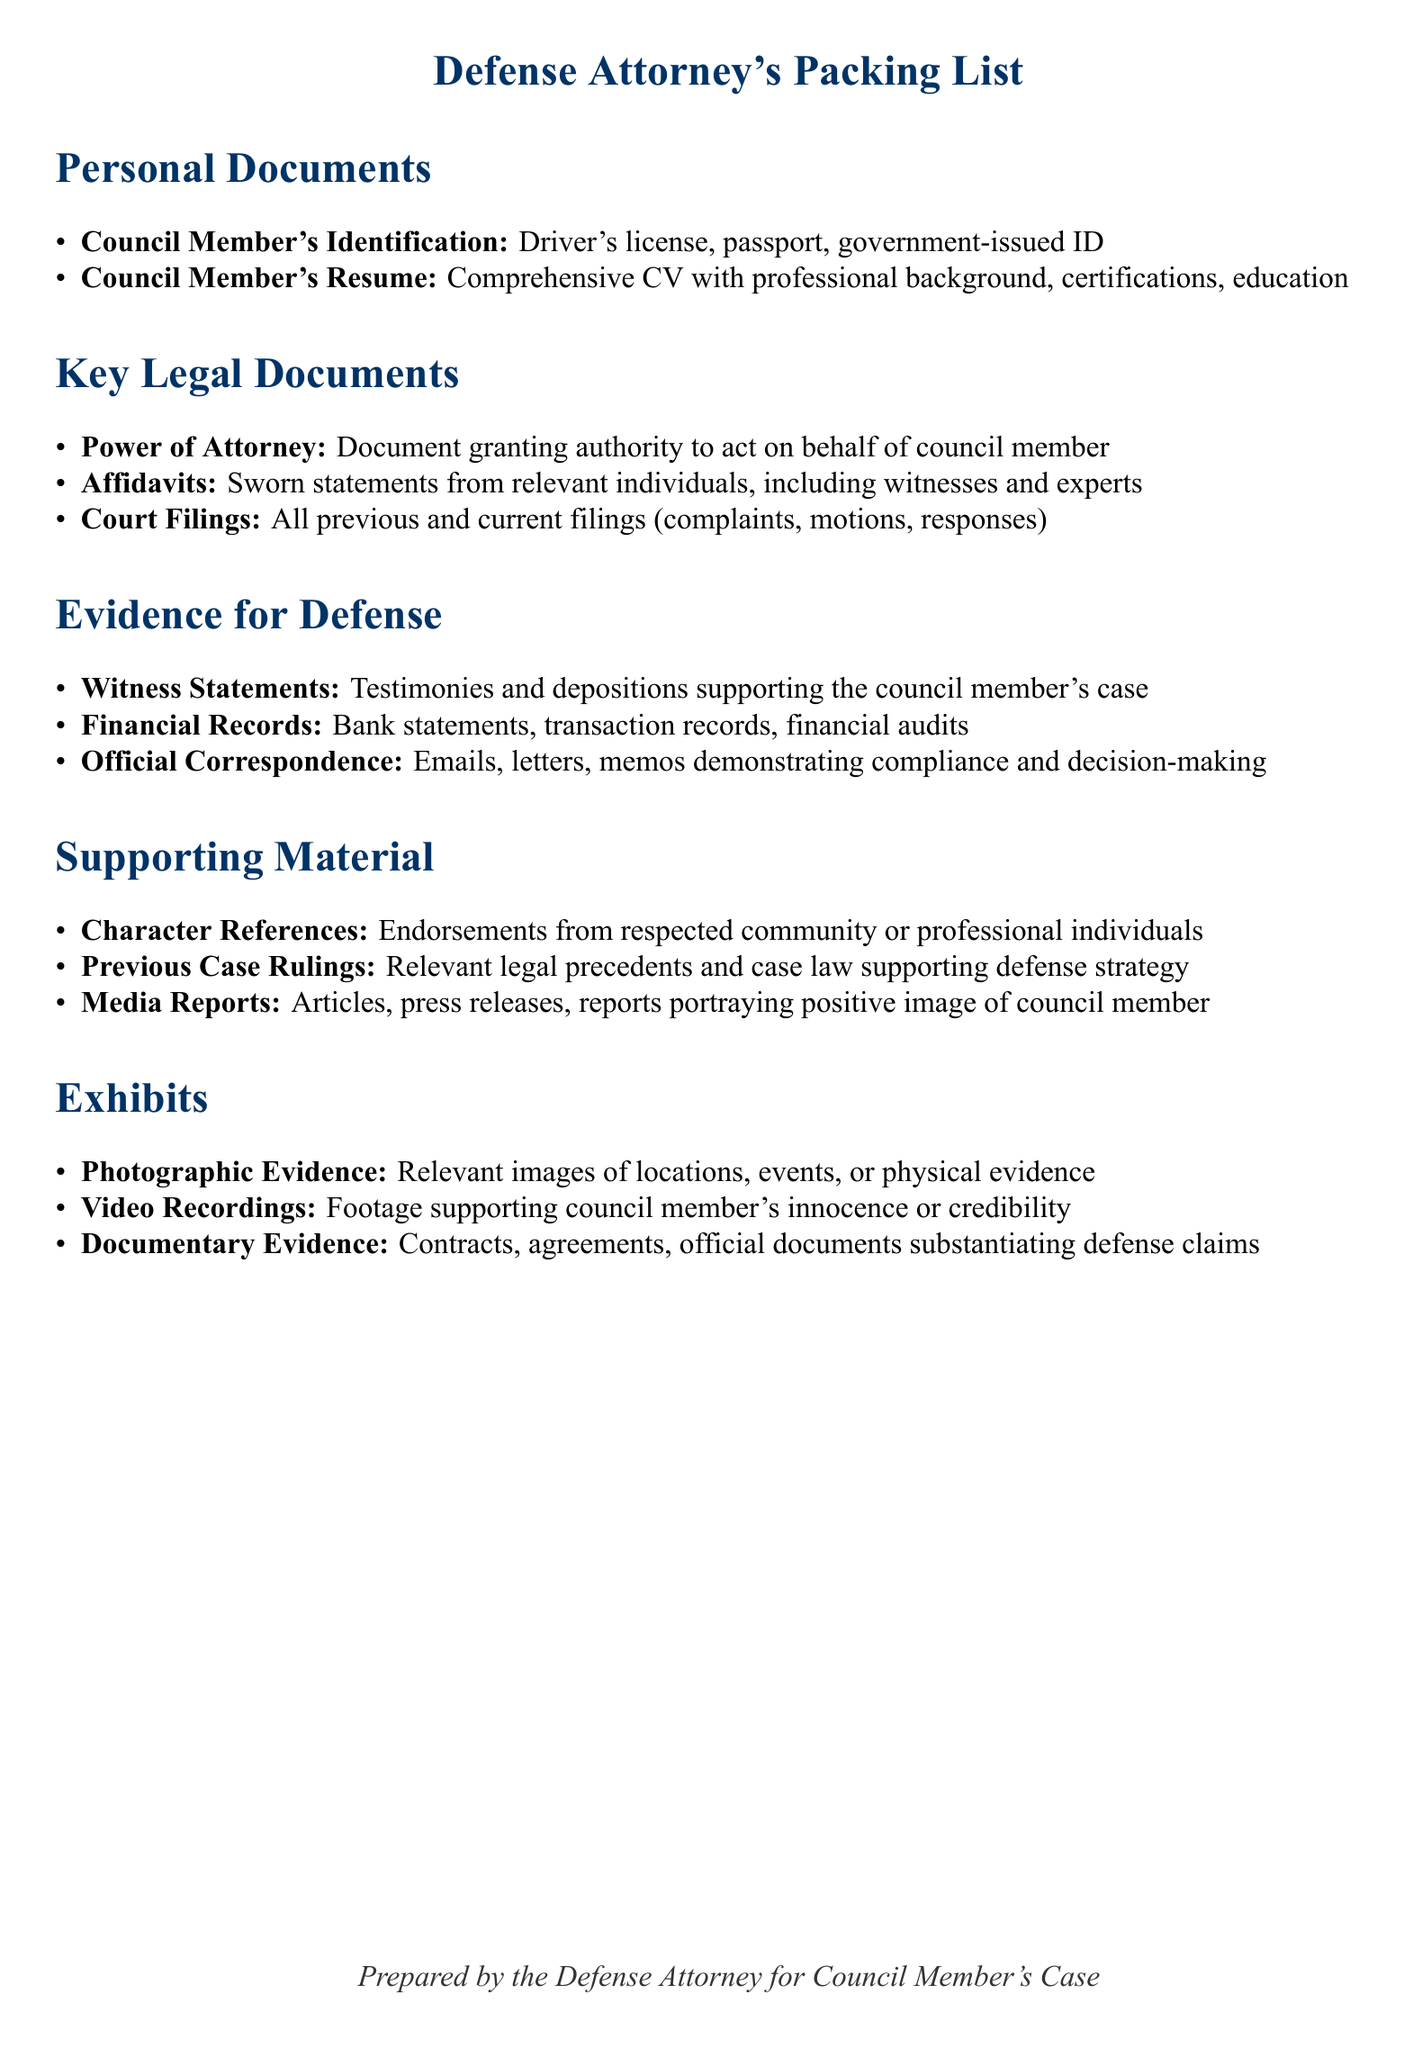What is included under Personal Documents? The section outlines what documents fall under Personal Documents, which include the council member's identification and resume.
Answer: Identification, Resume What type of statements must be included in Key Legal Documents? The document specifies that sworn statements from relevant individuals are to be included, indicating the type of statements required.
Answer: Affidavits What kind of records are specified as Evidence for Defense? The Evidence for Defense section lists financial records, highlighting the importance of financial documentation in the case.
Answer: Financial Records What is one example of Supporting Material mentioned? The document provides examples of additional materials that support the defense, one of which is character references.
Answer: Character References What forms of evidence are categorized as Exhibits? The Exhibits section describes the types of evidence categorized as exhibits, which include photographic evidence and video recordings.
Answer: Photographic Evidence, Video Recordings How many sections are included in the packing list? The document has several sections, and the total number of sections is crucial for understanding its organization.
Answer: Five What is the purpose of the Power of Attorney document? The packing list specifically states the purpose of this legal document within the context of representation.
Answer: Authority to act Which section includes relevant case law? The Supporting Material section explicitly mentions inclusion of legal precedents that support defense strategy, indicating which section to look for them.
Answer: Previous Case Rulings What type of correspondence is important for demonstrating compliance? The section on Evidence for Defense points out a specific type of correspondence that is crucial for the case.
Answer: Official Correspondence 